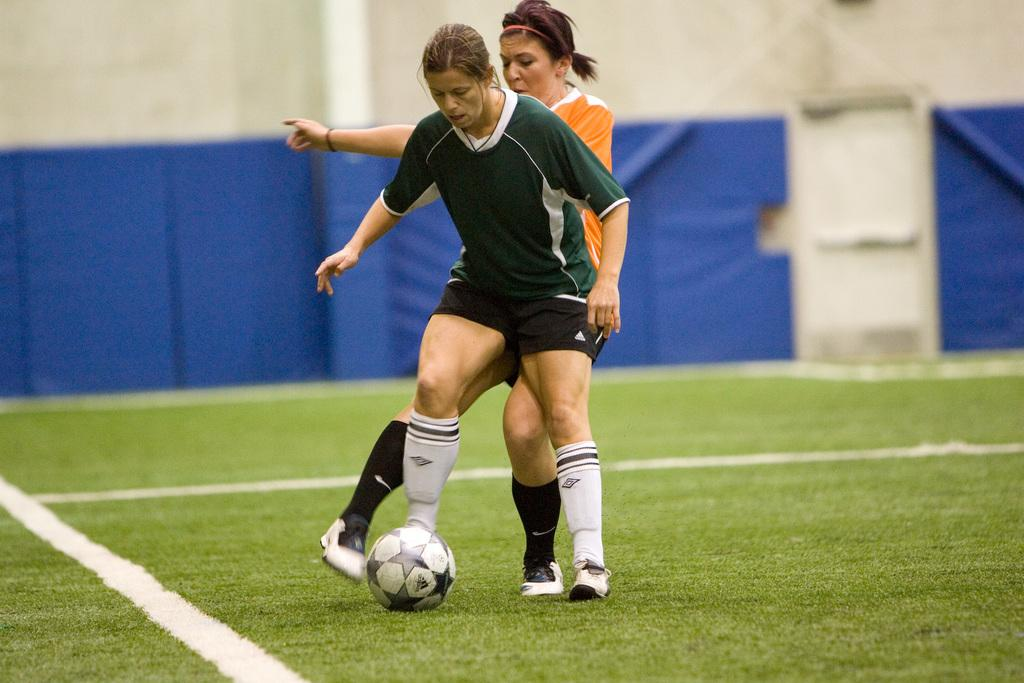How many people are in the image? There are two women in the image. What are the women doing in the image? Both women are playing football. Can you describe the outfits of the women in the image? One woman is wearing a green outfit, and the other woman is wearing an orange outfit. What actions are the women taking in relation to the football? The woman in green is trying to kick the ball, while the woman in orange is trying to avoid the ball. What type of juice can be seen in the image? There is no juice present in the image; it features two women playing football. How many frogs are visible in the image? There are no frogs visible in the image; it features two women playing football. 